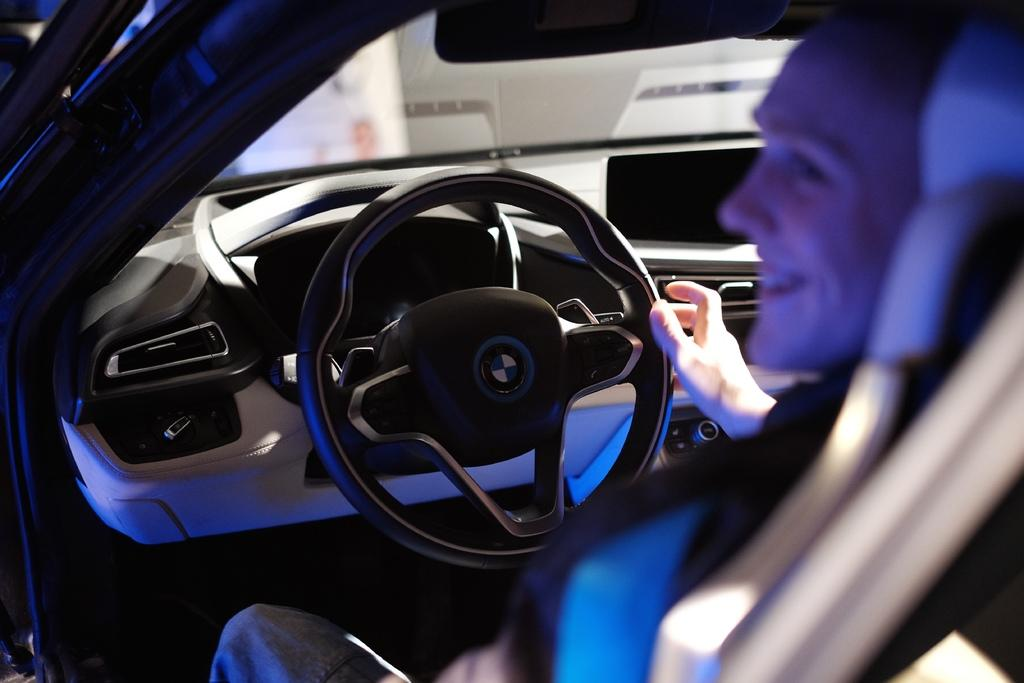Who is present in the image? There is a person in the image. What is the person doing in the image? The person is sitting in a car. What is the person's role in the car? The person is driving the car. What type of ball is the frog sitting on in the image? There is no frog or ball present in the image; it features a person sitting in a car and driving. 